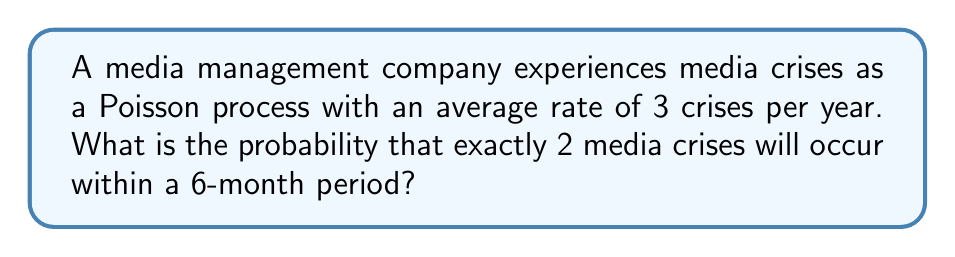Show me your answer to this math problem. To solve this problem, we'll use the Poisson distribution formula. The steps are as follows:

1. Identify the parameters:
   - Rate (λ) = 3 crises per year
   - Time period (t) = 6 months = 0.5 years
   - Number of events (k) = 2

2. Calculate the adjusted rate for the given time period:
   λ' = λ * t = 3 * 0.5 = 1.5

3. Apply the Poisson probability formula:
   $$P(X = k) = \frac{e^{-λ'} * (λ')^k}{k!}$$

4. Substitute the values:
   $$P(X = 2) = \frac{e^{-1.5} * (1.5)^2}{2!}$$

5. Calculate step by step:
   $$P(X = 2) = \frac{e^{-1.5} * 2.25}{2}$$
   $$P(X = 2) = \frac{0.2231 * 2.25}{2}$$
   $$P(X = 2) = \frac{0.5020}{2}$$
   $$P(X = 2) = 0.2510$$

6. Round to four decimal places:
   P(X = 2) ≈ 0.2510

Therefore, the probability of exactly 2 media crises occurring within a 6-month period is approximately 0.2510 or 25.10%.
Answer: 0.2510 